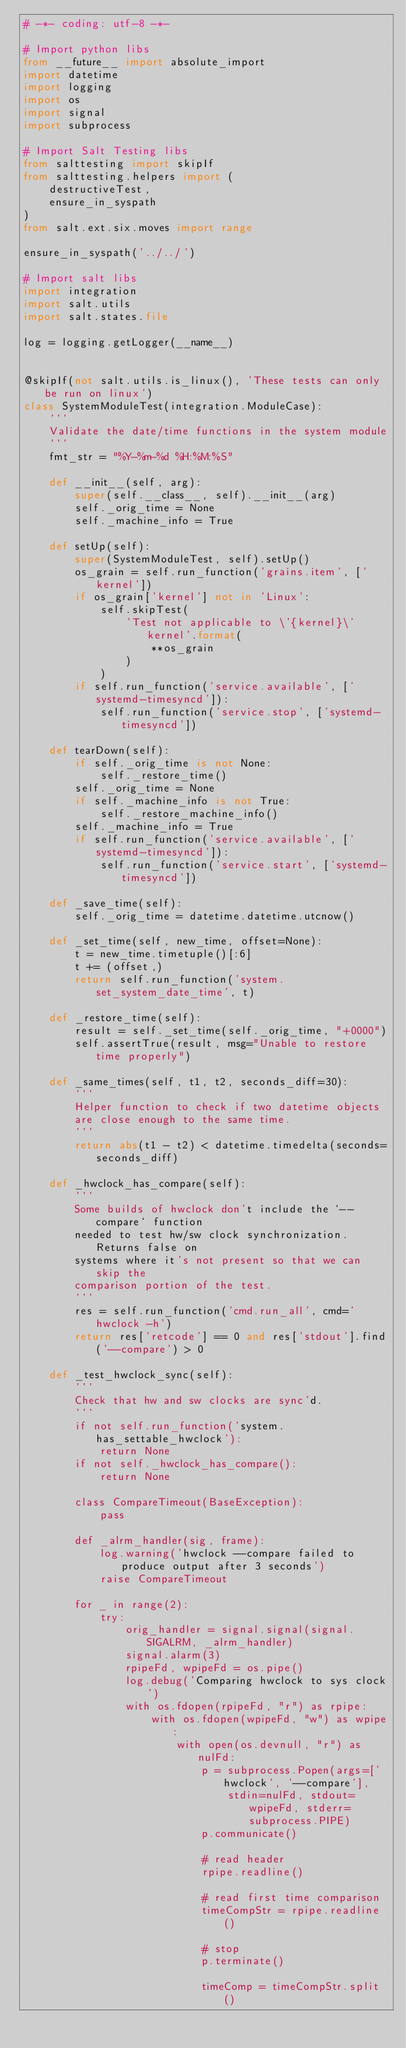<code> <loc_0><loc_0><loc_500><loc_500><_Python_># -*- coding: utf-8 -*-

# Import python libs
from __future__ import absolute_import
import datetime
import logging
import os
import signal
import subprocess

# Import Salt Testing libs
from salttesting import skipIf
from salttesting.helpers import (
    destructiveTest,
    ensure_in_syspath
)
from salt.ext.six.moves import range

ensure_in_syspath('../../')

# Import salt libs
import integration
import salt.utils
import salt.states.file

log = logging.getLogger(__name__)


@skipIf(not salt.utils.is_linux(), 'These tests can only be run on linux')
class SystemModuleTest(integration.ModuleCase):
    '''
    Validate the date/time functions in the system module
    '''
    fmt_str = "%Y-%m-%d %H:%M:%S"

    def __init__(self, arg):
        super(self.__class__, self).__init__(arg)
        self._orig_time = None
        self._machine_info = True

    def setUp(self):
        super(SystemModuleTest, self).setUp()
        os_grain = self.run_function('grains.item', ['kernel'])
        if os_grain['kernel'] not in 'Linux':
            self.skipTest(
                'Test not applicable to \'{kernel}\' kernel'.format(
                    **os_grain
                )
            )
        if self.run_function('service.available', ['systemd-timesyncd']):
            self.run_function('service.stop', ['systemd-timesyncd'])

    def tearDown(self):
        if self._orig_time is not None:
            self._restore_time()
        self._orig_time = None
        if self._machine_info is not True:
            self._restore_machine_info()
        self._machine_info = True
        if self.run_function('service.available', ['systemd-timesyncd']):
            self.run_function('service.start', ['systemd-timesyncd'])

    def _save_time(self):
        self._orig_time = datetime.datetime.utcnow()

    def _set_time(self, new_time, offset=None):
        t = new_time.timetuple()[:6]
        t += (offset,)
        return self.run_function('system.set_system_date_time', t)

    def _restore_time(self):
        result = self._set_time(self._orig_time, "+0000")
        self.assertTrue(result, msg="Unable to restore time properly")

    def _same_times(self, t1, t2, seconds_diff=30):
        '''
        Helper function to check if two datetime objects
        are close enough to the same time.
        '''
        return abs(t1 - t2) < datetime.timedelta(seconds=seconds_diff)

    def _hwclock_has_compare(self):
        '''
        Some builds of hwclock don't include the `--compare` function
        needed to test hw/sw clock synchronization. Returns false on
        systems where it's not present so that we can skip the
        comparison portion of the test.
        '''
        res = self.run_function('cmd.run_all', cmd='hwclock -h')
        return res['retcode'] == 0 and res['stdout'].find('--compare') > 0

    def _test_hwclock_sync(self):
        '''
        Check that hw and sw clocks are sync'd.
        '''
        if not self.run_function('system.has_settable_hwclock'):
            return None
        if not self._hwclock_has_compare():
            return None

        class CompareTimeout(BaseException):
            pass

        def _alrm_handler(sig, frame):
            log.warning('hwclock --compare failed to produce output after 3 seconds')
            raise CompareTimeout

        for _ in range(2):
            try:
                orig_handler = signal.signal(signal.SIGALRM, _alrm_handler)
                signal.alarm(3)
                rpipeFd, wpipeFd = os.pipe()
                log.debug('Comparing hwclock to sys clock')
                with os.fdopen(rpipeFd, "r") as rpipe:
                    with os.fdopen(wpipeFd, "w") as wpipe:
                        with open(os.devnull, "r") as nulFd:
                            p = subprocess.Popen(args=['hwclock', '--compare'],
                                stdin=nulFd, stdout=wpipeFd, stderr=subprocess.PIPE)
                            p.communicate()

                            # read header
                            rpipe.readline()

                            # read first time comparison
                            timeCompStr = rpipe.readline()

                            # stop
                            p.terminate()

                            timeComp = timeCompStr.split()</code> 